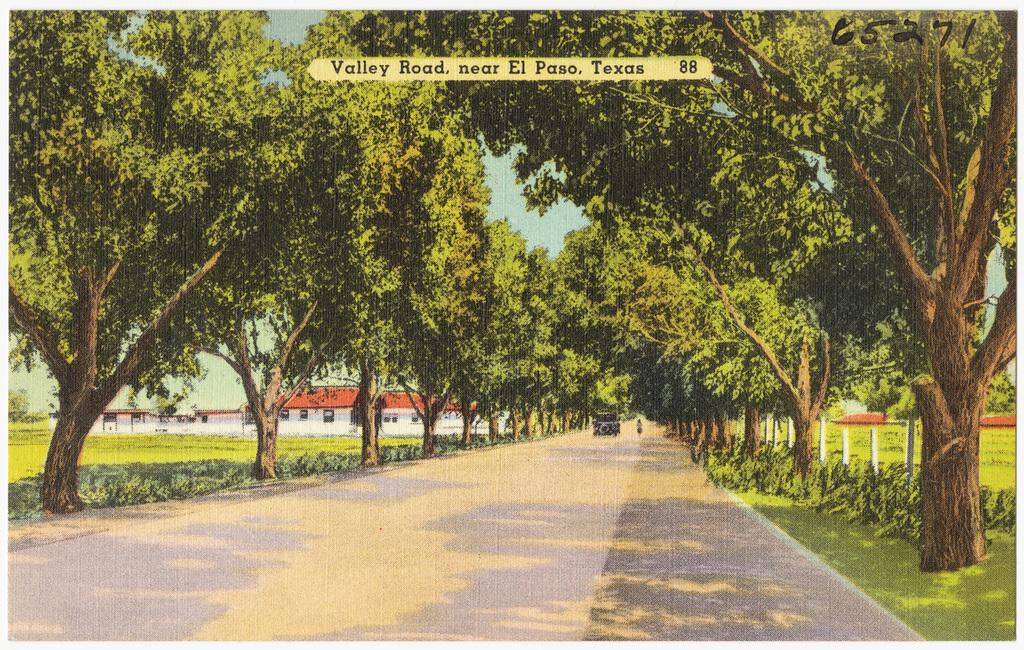What type of vegetation can be seen in the image? There are trees in the image. What type of structures are present in the image? There are buildings in the image. What type of ground cover is visible in the image? There is grass visible in the image. How many quince are hanging from the trees in the image? There are no quince visible in the image; only trees are present. What letters can be seen on the buildings in the image? There is no information about letters on the buildings in the image. 